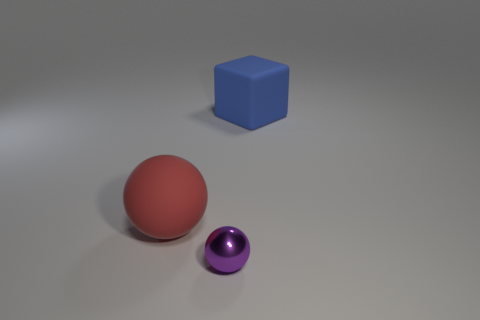The thing that is the same size as the block is what shape?
Your answer should be compact. Sphere. The large matte thing that is behind the big thing to the left of the small purple sphere in front of the large blue matte cube is what shape?
Your answer should be very brief. Cube. Are there an equal number of purple balls that are left of the shiny object and red objects?
Offer a terse response. No. Does the rubber block have the same size as the metallic ball?
Your answer should be compact. No. What number of matte objects are either large balls or small purple objects?
Your answer should be compact. 1. There is a red object that is the same size as the cube; what is it made of?
Ensure brevity in your answer.  Rubber. How many other objects are the same material as the purple sphere?
Ensure brevity in your answer.  0. Are there fewer matte spheres that are on the right side of the red sphere than metallic objects?
Provide a short and direct response. Yes. Does the small thing have the same shape as the red thing?
Make the answer very short. Yes. How big is the object that is in front of the matte thing in front of the rubber object to the right of the large rubber sphere?
Your answer should be compact. Small. 